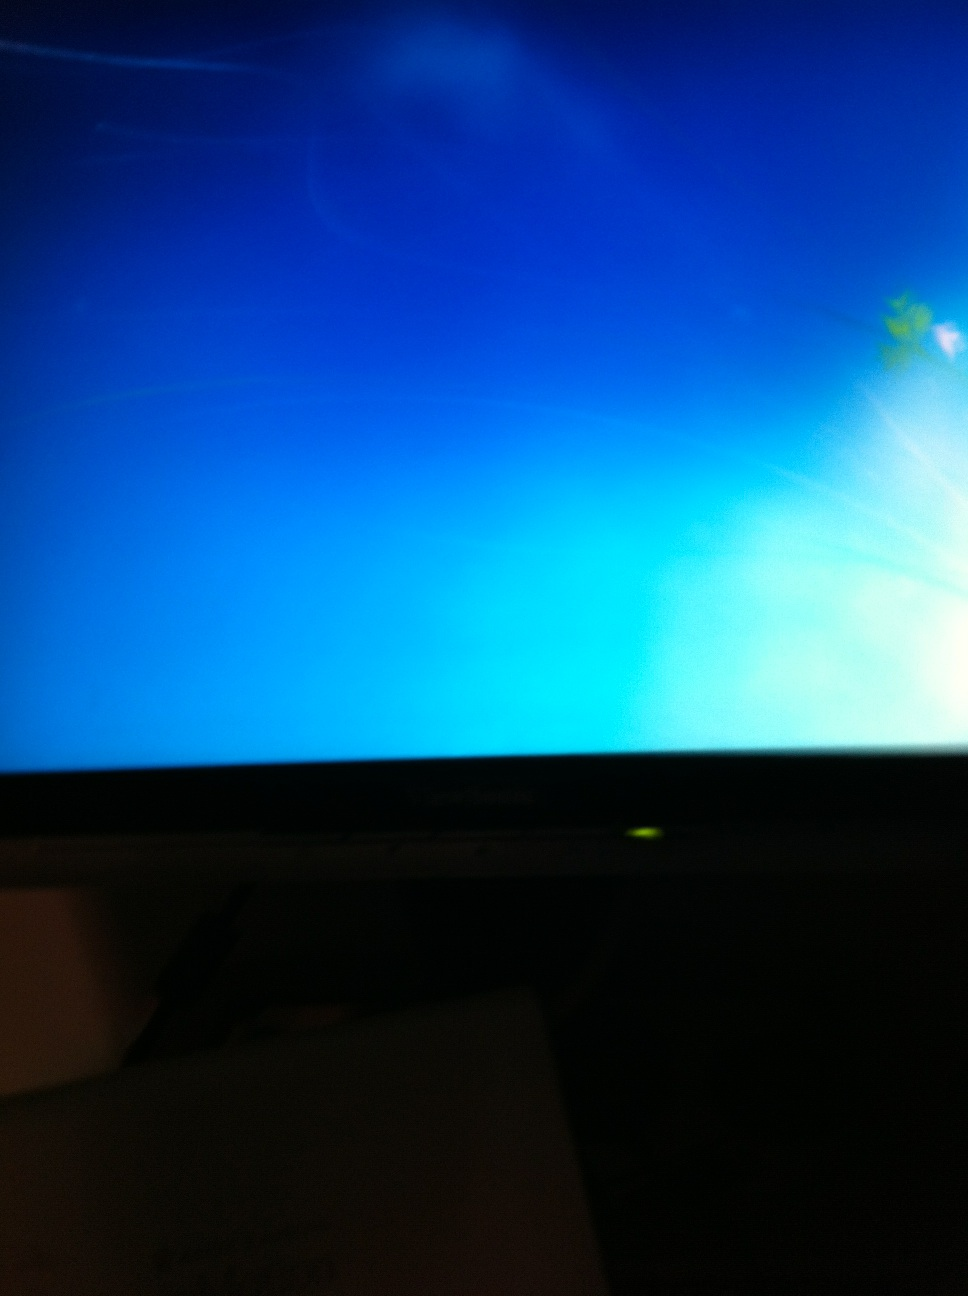Could the problem be related to hardware failure, and how could I confirm it? Hardware failures can indeed prevent a computer from booting. Common signs include unusual noises, like continuous beeping or clicking sounds from the hard drive. To confirm, you can open the case (if you're comfortable with it) and check for any visibly damaged components, reseat the RAM, or try to boot with minimal hardware connected. Using a diagnostic tool provided by the PC manufacturer, if available, can also help identify hardware issues. 